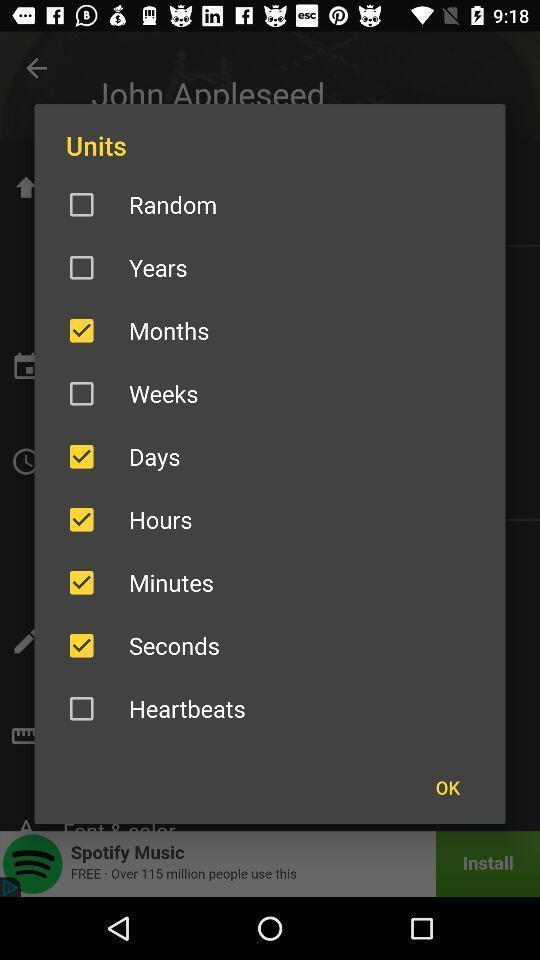Describe this image in words. Pop-up to select the units. 